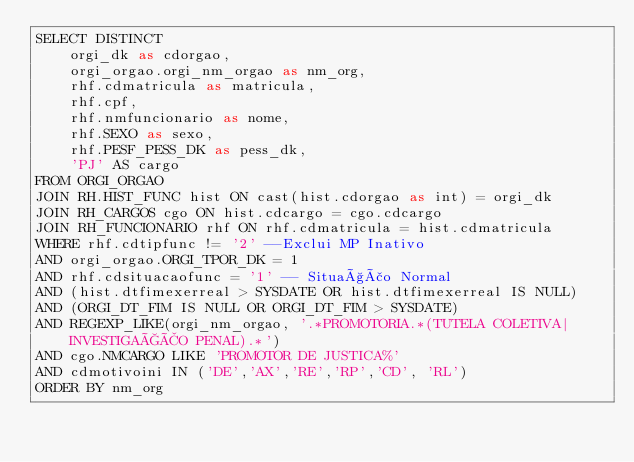Convert code to text. <code><loc_0><loc_0><loc_500><loc_500><_SQL_>SELECT DISTINCT
    orgi_dk as cdorgao,
    orgi_orgao.orgi_nm_orgao as nm_org,
    rhf.cdmatricula as matricula,
    rhf.cpf,
    rhf.nmfuncionario as nome,
    rhf.SEXO as sexo,
    rhf.PESF_PESS_DK as pess_dk,
    'PJ' AS cargo
FROM ORGI_ORGAO
JOIN RH.HIST_FUNC hist ON cast(hist.cdorgao as int) = orgi_dk
JOIN RH_CARGOS cgo ON hist.cdcargo = cgo.cdcargo
JOIN RH_FUNCIONARIO rhf ON rhf.cdmatricula = hist.cdmatricula
WHERE rhf.cdtipfunc != '2' --Exclui MP Inativo
AND orgi_orgao.ORGI_TPOR_DK = 1
AND rhf.cdsituacaofunc = '1' -- Situação Normal
AND (hist.dtfimexerreal > SYSDATE OR hist.dtfimexerreal IS NULL)
AND (ORGI_DT_FIM IS NULL OR ORGI_DT_FIM > SYSDATE)
AND REGEXP_LIKE(orgi_nm_orgao, '.*PROMOTORIA.*(TUTELA COLETIVA|INVESTIGAÇÃO PENAL).*')
AND cgo.NMCARGO LIKE 'PROMOTOR DE JUSTICA%'
AND cdmotivoini IN ('DE','AX','RE','RP','CD', 'RL')
ORDER BY nm_org</code> 